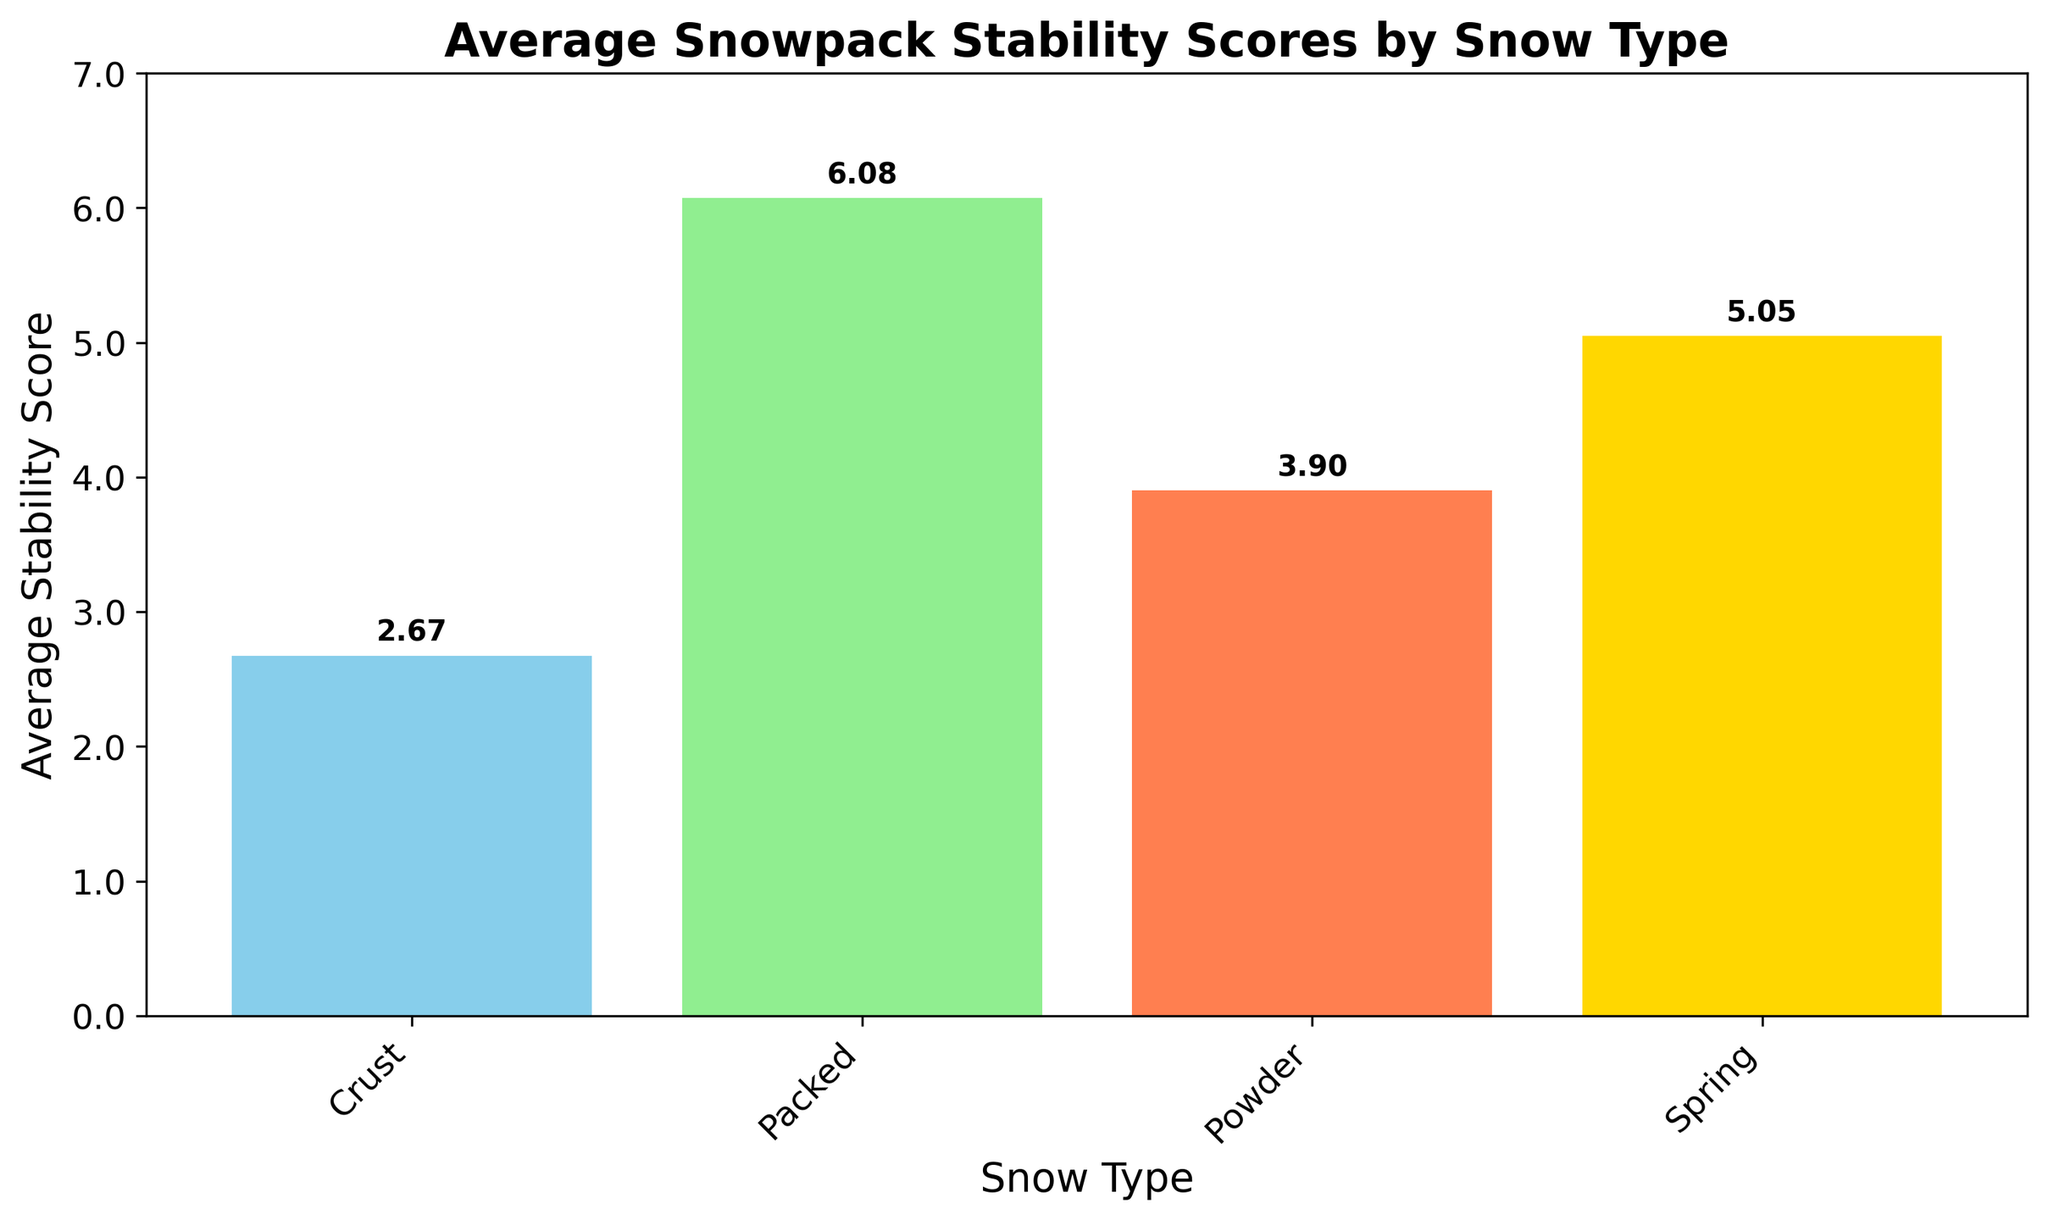What is the average stability score for Powder snow type? The bar height for Powder snow indicates the average stability score. Refer to the label on top of the Powder bar.
Answer: 3.9 Which snow type has the highest average stability score? Compare the heights of all the bars. The bar representing Packed snow is the tallest.
Answer: Packed How much higher is the average stability score of Packed snow compared to Crust snow? Subtract the height of the Crust bar from the height of the Packed bar. Packed: 6.1 - Crust: 2.68 = 3.42
Answer: 3.42 Which snow type has the lowest average stability score? Identify the shortest bar. The bar representing Crust snow is the shortest.
Answer: Crust Compare the average stability scores of Spring and Powder snow types. Which one is higher? Look at the heights of the bars for Spring and Powder snow types. The Spring bar is higher.
Answer: Spring What is the average stability score for the snow type with the third highest average score? Order the snow types by bar height. The third highest bar corresponds to Spring snow. The average stability score for Spring is the bar height.
Answer: 5.05 How does the stability score of Powder snow compare to the stability score of Crust snow? Compare the heights of the bars for Powder and Crust snow types. Powder bar is taller than Crust bar.
Answer: Powder is higher If you sum the average stability scores for all snow types, what is the total? Add the heights of all the bars together. Powder: 3.9 + Packed: 6.1 + Crust: 2.68 + Spring: 5.05 = 17.73
Answer: 17.73 Which two snow types have the closest average stability scores, and what is the difference between them? Compare the heights of adjacent bars to find the smallest difference. The closest are Powder and Spring. Difference: Spring 5.05 - Powder 3.9 = 1.15
Answer: Powder and Spring, 1.15 What percentage of the highest stability score is the stability score of Crust snow? Divide the Crust bar height by the Packed bar height and multiply by 100 to get the percentage. (2.68 / 6.1) * 100 ≈ 43.93%
Answer: ~43.93% 